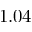<formula> <loc_0><loc_0><loc_500><loc_500>1 . 0 4</formula> 